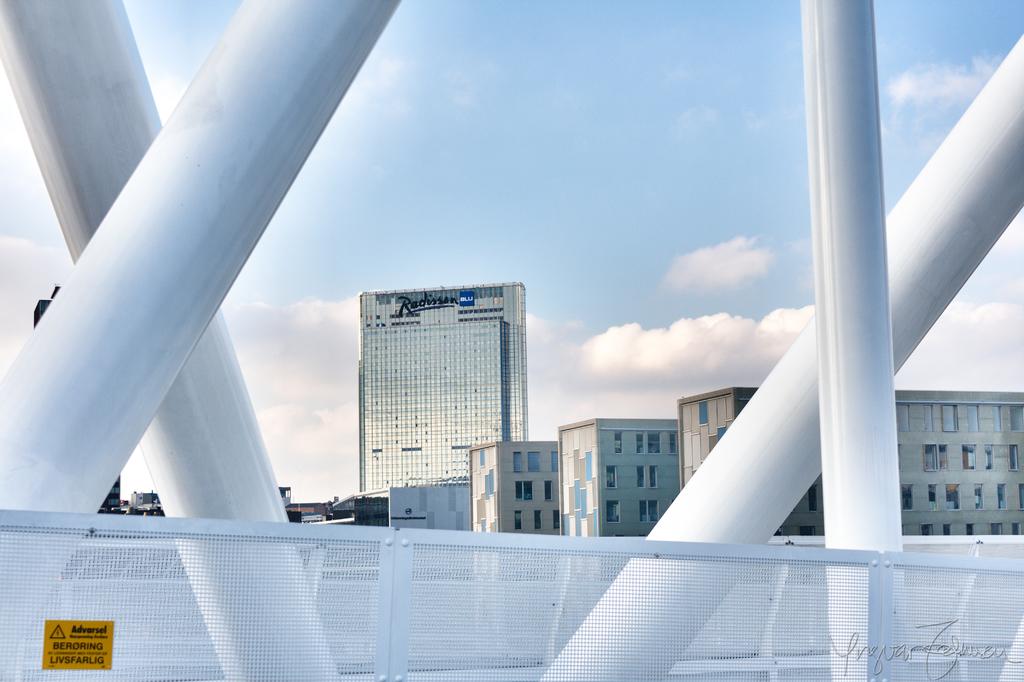What is the name of the hotel?
Offer a terse response. Radisson. What is written on the yellow sign?
Your answer should be compact. Advarsel. 